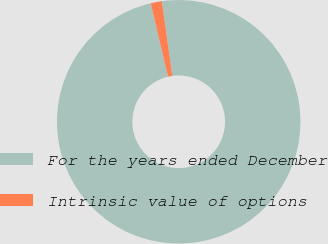Convert chart. <chart><loc_0><loc_0><loc_500><loc_500><pie_chart><fcel>For the years ended December<fcel>Intrinsic value of options<nl><fcel>98.52%<fcel>1.48%<nl></chart> 